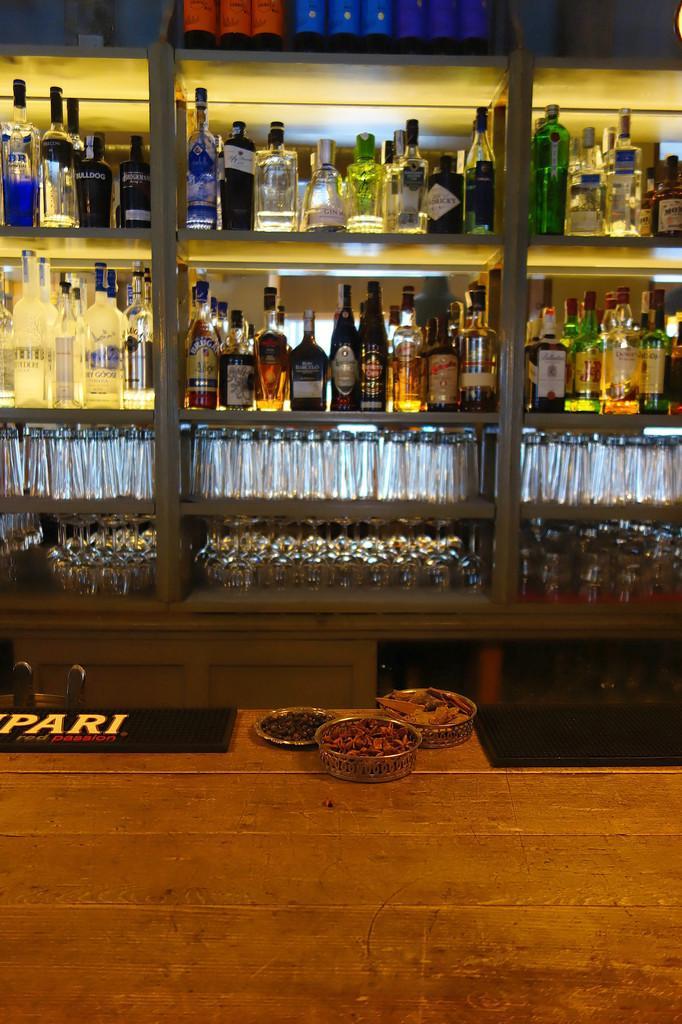Describe this image in one or two sentences. There are wine bottles in these racks and glasses in these. 